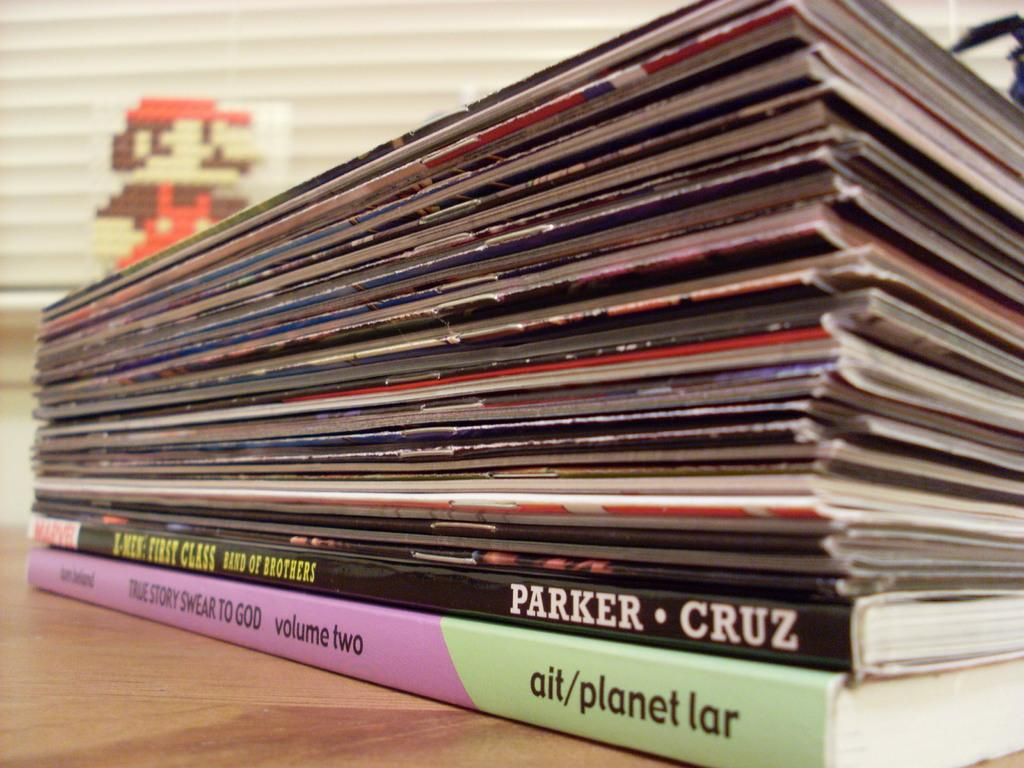<image>
Give a short and clear explanation of the subsequent image. A collection of books stacked but the bottom on says ait/planet lar. 